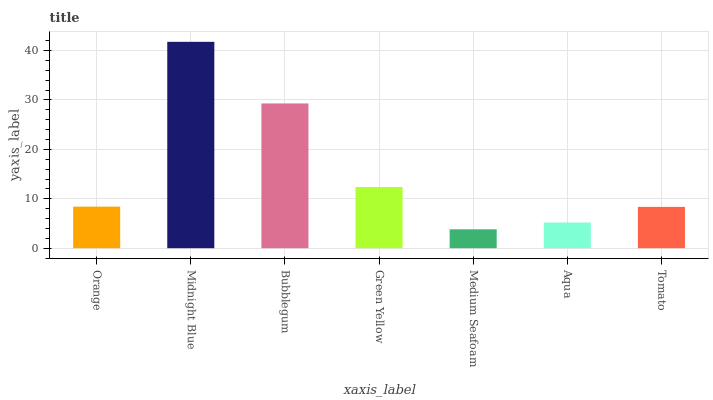Is Medium Seafoam the minimum?
Answer yes or no. Yes. Is Midnight Blue the maximum?
Answer yes or no. Yes. Is Bubblegum the minimum?
Answer yes or no. No. Is Bubblegum the maximum?
Answer yes or no. No. Is Midnight Blue greater than Bubblegum?
Answer yes or no. Yes. Is Bubblegum less than Midnight Blue?
Answer yes or no. Yes. Is Bubblegum greater than Midnight Blue?
Answer yes or no. No. Is Midnight Blue less than Bubblegum?
Answer yes or no. No. Is Orange the high median?
Answer yes or no. Yes. Is Orange the low median?
Answer yes or no. Yes. Is Medium Seafoam the high median?
Answer yes or no. No. Is Green Yellow the low median?
Answer yes or no. No. 